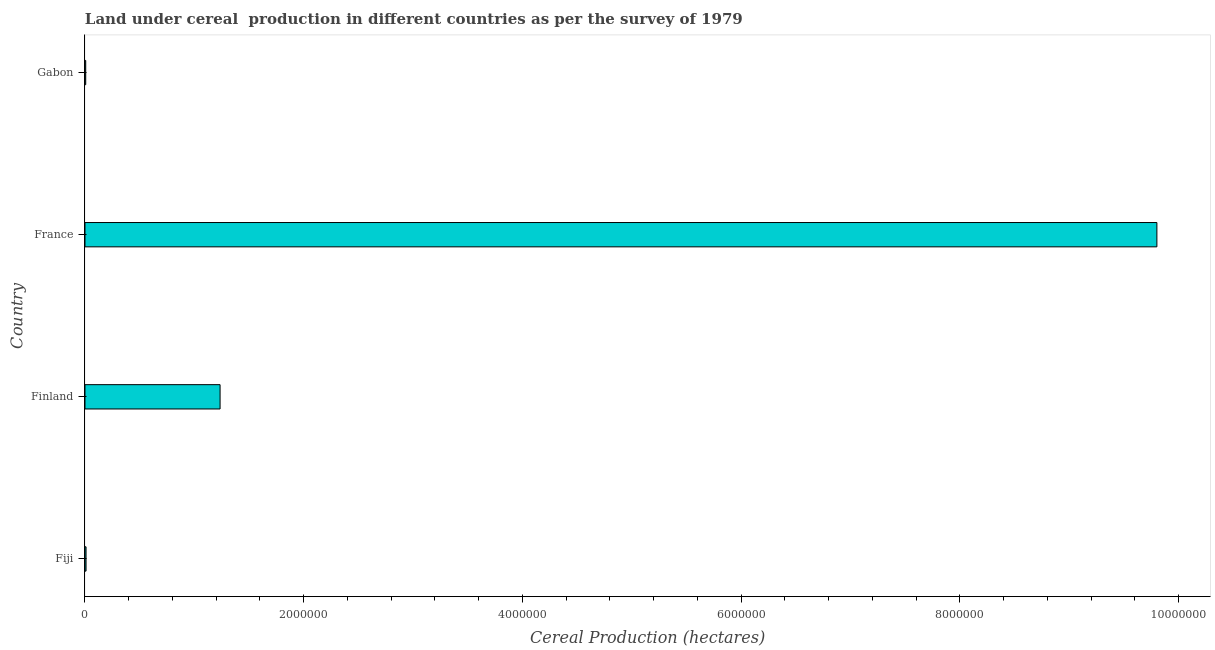Does the graph contain any zero values?
Provide a succinct answer. No. What is the title of the graph?
Provide a short and direct response. Land under cereal  production in different countries as per the survey of 1979. What is the label or title of the X-axis?
Your response must be concise. Cereal Production (hectares). What is the land under cereal production in Finland?
Your response must be concise. 1.24e+06. Across all countries, what is the maximum land under cereal production?
Ensure brevity in your answer.  9.80e+06. Across all countries, what is the minimum land under cereal production?
Ensure brevity in your answer.  6800. In which country was the land under cereal production maximum?
Offer a very short reply. France. In which country was the land under cereal production minimum?
Ensure brevity in your answer.  Gabon. What is the sum of the land under cereal production?
Keep it short and to the point. 1.11e+07. What is the difference between the land under cereal production in Fiji and Gabon?
Keep it short and to the point. 3071. What is the average land under cereal production per country?
Keep it short and to the point. 2.76e+06. What is the median land under cereal production?
Give a very brief answer. 6.23e+05. In how many countries, is the land under cereal production greater than 6000000 hectares?
Your answer should be compact. 1. What is the ratio of the land under cereal production in France to that in Gabon?
Provide a short and direct response. 1441.52. Is the land under cereal production in France less than that in Gabon?
Your answer should be compact. No. What is the difference between the highest and the second highest land under cereal production?
Give a very brief answer. 8.57e+06. What is the difference between the highest and the lowest land under cereal production?
Your answer should be very brief. 9.80e+06. In how many countries, is the land under cereal production greater than the average land under cereal production taken over all countries?
Your response must be concise. 1. Are all the bars in the graph horizontal?
Provide a short and direct response. Yes. What is the difference between two consecutive major ticks on the X-axis?
Offer a very short reply. 2.00e+06. Are the values on the major ticks of X-axis written in scientific E-notation?
Ensure brevity in your answer.  No. What is the Cereal Production (hectares) of Fiji?
Give a very brief answer. 9871. What is the Cereal Production (hectares) in Finland?
Offer a terse response. 1.24e+06. What is the Cereal Production (hectares) of France?
Provide a succinct answer. 9.80e+06. What is the Cereal Production (hectares) in Gabon?
Offer a terse response. 6800. What is the difference between the Cereal Production (hectares) in Fiji and Finland?
Offer a very short reply. -1.23e+06. What is the difference between the Cereal Production (hectares) in Fiji and France?
Your answer should be compact. -9.79e+06. What is the difference between the Cereal Production (hectares) in Fiji and Gabon?
Ensure brevity in your answer.  3071. What is the difference between the Cereal Production (hectares) in Finland and France?
Ensure brevity in your answer.  -8.57e+06. What is the difference between the Cereal Production (hectares) in Finland and Gabon?
Ensure brevity in your answer.  1.23e+06. What is the difference between the Cereal Production (hectares) in France and Gabon?
Make the answer very short. 9.80e+06. What is the ratio of the Cereal Production (hectares) in Fiji to that in Finland?
Your answer should be compact. 0.01. What is the ratio of the Cereal Production (hectares) in Fiji to that in France?
Your answer should be compact. 0. What is the ratio of the Cereal Production (hectares) in Fiji to that in Gabon?
Give a very brief answer. 1.45. What is the ratio of the Cereal Production (hectares) in Finland to that in France?
Give a very brief answer. 0.13. What is the ratio of the Cereal Production (hectares) in Finland to that in Gabon?
Make the answer very short. 181.69. What is the ratio of the Cereal Production (hectares) in France to that in Gabon?
Your answer should be compact. 1441.52. 